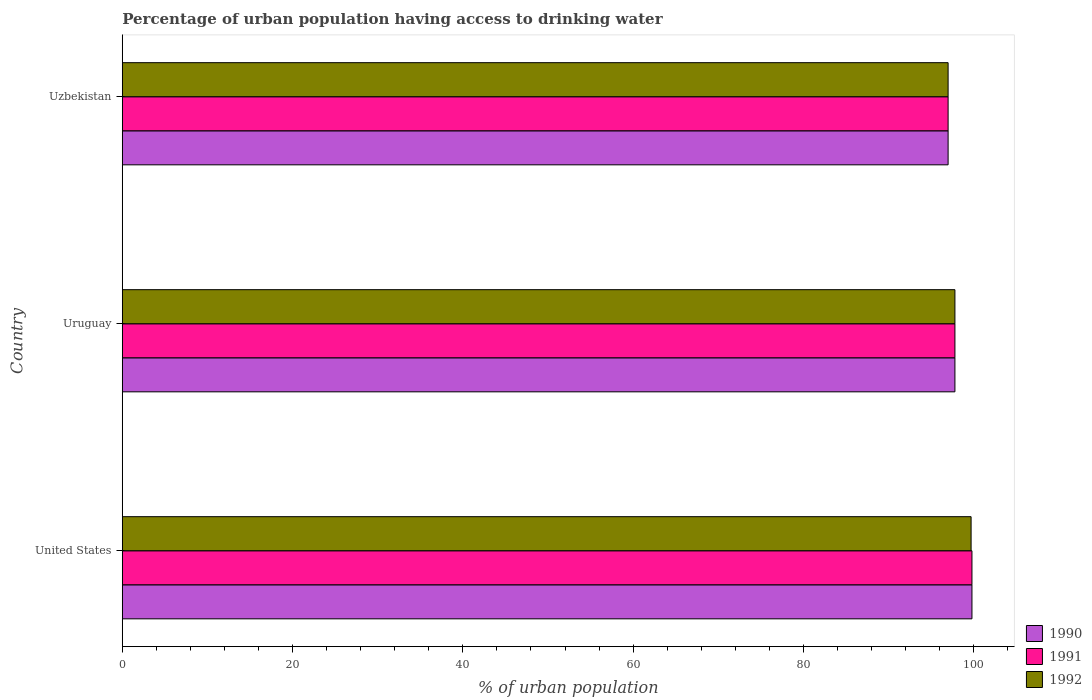How many different coloured bars are there?
Offer a very short reply. 3. Are the number of bars on each tick of the Y-axis equal?
Provide a short and direct response. Yes. How many bars are there on the 2nd tick from the top?
Make the answer very short. 3. What is the label of the 3rd group of bars from the top?
Your answer should be compact. United States. In how many cases, is the number of bars for a given country not equal to the number of legend labels?
Provide a succinct answer. 0. What is the percentage of urban population having access to drinking water in 1990 in Uzbekistan?
Your answer should be compact. 97. Across all countries, what is the maximum percentage of urban population having access to drinking water in 1990?
Provide a succinct answer. 99.8. Across all countries, what is the minimum percentage of urban population having access to drinking water in 1992?
Keep it short and to the point. 97. In which country was the percentage of urban population having access to drinking water in 1992 minimum?
Ensure brevity in your answer.  Uzbekistan. What is the total percentage of urban population having access to drinking water in 1992 in the graph?
Your answer should be compact. 294.5. What is the difference between the percentage of urban population having access to drinking water in 1990 in United States and that in Uruguay?
Your answer should be compact. 2. What is the difference between the percentage of urban population having access to drinking water in 1990 in United States and the percentage of urban population having access to drinking water in 1992 in Uruguay?
Provide a succinct answer. 2. What is the average percentage of urban population having access to drinking water in 1990 per country?
Provide a short and direct response. 98.2. What is the difference between the percentage of urban population having access to drinking water in 1990 and percentage of urban population having access to drinking water in 1992 in Uzbekistan?
Provide a succinct answer. 0. In how many countries, is the percentage of urban population having access to drinking water in 1990 greater than 20 %?
Provide a succinct answer. 3. What is the ratio of the percentage of urban population having access to drinking water in 1990 in United States to that in Uzbekistan?
Offer a very short reply. 1.03. Is the percentage of urban population having access to drinking water in 1992 in United States less than that in Uruguay?
Offer a very short reply. No. Is the difference between the percentage of urban population having access to drinking water in 1990 in United States and Uruguay greater than the difference between the percentage of urban population having access to drinking water in 1992 in United States and Uruguay?
Ensure brevity in your answer.  Yes. What is the difference between the highest and the second highest percentage of urban population having access to drinking water in 1990?
Make the answer very short. 2. What is the difference between the highest and the lowest percentage of urban population having access to drinking water in 1992?
Make the answer very short. 2.7. In how many countries, is the percentage of urban population having access to drinking water in 1990 greater than the average percentage of urban population having access to drinking water in 1990 taken over all countries?
Your answer should be compact. 1. What does the 3rd bar from the top in United States represents?
Provide a short and direct response. 1990. What does the 3rd bar from the bottom in Uzbekistan represents?
Provide a succinct answer. 1992. What is the difference between two consecutive major ticks on the X-axis?
Give a very brief answer. 20. Are the values on the major ticks of X-axis written in scientific E-notation?
Your response must be concise. No. Does the graph contain any zero values?
Your response must be concise. No. Where does the legend appear in the graph?
Provide a succinct answer. Bottom right. How many legend labels are there?
Give a very brief answer. 3. What is the title of the graph?
Offer a terse response. Percentage of urban population having access to drinking water. What is the label or title of the X-axis?
Give a very brief answer. % of urban population. What is the % of urban population in 1990 in United States?
Give a very brief answer. 99.8. What is the % of urban population of 1991 in United States?
Ensure brevity in your answer.  99.8. What is the % of urban population of 1992 in United States?
Give a very brief answer. 99.7. What is the % of urban population in 1990 in Uruguay?
Your answer should be very brief. 97.8. What is the % of urban population of 1991 in Uruguay?
Keep it short and to the point. 97.8. What is the % of urban population in 1992 in Uruguay?
Your response must be concise. 97.8. What is the % of urban population in 1990 in Uzbekistan?
Your answer should be very brief. 97. What is the % of urban population of 1991 in Uzbekistan?
Offer a terse response. 97. What is the % of urban population in 1992 in Uzbekistan?
Your response must be concise. 97. Across all countries, what is the maximum % of urban population of 1990?
Give a very brief answer. 99.8. Across all countries, what is the maximum % of urban population of 1991?
Keep it short and to the point. 99.8. Across all countries, what is the maximum % of urban population of 1992?
Provide a succinct answer. 99.7. Across all countries, what is the minimum % of urban population of 1990?
Keep it short and to the point. 97. Across all countries, what is the minimum % of urban population of 1991?
Your answer should be compact. 97. Across all countries, what is the minimum % of urban population of 1992?
Your answer should be very brief. 97. What is the total % of urban population in 1990 in the graph?
Offer a terse response. 294.6. What is the total % of urban population in 1991 in the graph?
Give a very brief answer. 294.6. What is the total % of urban population in 1992 in the graph?
Offer a very short reply. 294.5. What is the difference between the % of urban population in 1990 in United States and that in Uruguay?
Provide a short and direct response. 2. What is the difference between the % of urban population of 1991 in United States and that in Uruguay?
Offer a very short reply. 2. What is the difference between the % of urban population in 1991 in United States and that in Uzbekistan?
Provide a succinct answer. 2.8. What is the difference between the % of urban population in 1990 in United States and the % of urban population in 1991 in Uruguay?
Keep it short and to the point. 2. What is the difference between the % of urban population of 1991 in United States and the % of urban population of 1992 in Uruguay?
Make the answer very short. 2. What is the difference between the % of urban population in 1990 in United States and the % of urban population in 1991 in Uzbekistan?
Your answer should be compact. 2.8. What is the difference between the % of urban population in 1991 in United States and the % of urban population in 1992 in Uzbekistan?
Your response must be concise. 2.8. What is the difference between the % of urban population in 1990 in Uruguay and the % of urban population in 1992 in Uzbekistan?
Ensure brevity in your answer.  0.8. What is the difference between the % of urban population in 1991 in Uruguay and the % of urban population in 1992 in Uzbekistan?
Give a very brief answer. 0.8. What is the average % of urban population of 1990 per country?
Provide a succinct answer. 98.2. What is the average % of urban population of 1991 per country?
Offer a terse response. 98.2. What is the average % of urban population of 1992 per country?
Provide a succinct answer. 98.17. What is the difference between the % of urban population of 1991 and % of urban population of 1992 in United States?
Your answer should be compact. 0.1. What is the difference between the % of urban population in 1990 and % of urban population in 1991 in Uzbekistan?
Your response must be concise. 0. What is the ratio of the % of urban population in 1990 in United States to that in Uruguay?
Provide a short and direct response. 1.02. What is the ratio of the % of urban population of 1991 in United States to that in Uruguay?
Give a very brief answer. 1.02. What is the ratio of the % of urban population of 1992 in United States to that in Uruguay?
Provide a short and direct response. 1.02. What is the ratio of the % of urban population in 1990 in United States to that in Uzbekistan?
Offer a terse response. 1.03. What is the ratio of the % of urban population of 1991 in United States to that in Uzbekistan?
Make the answer very short. 1.03. What is the ratio of the % of urban population in 1992 in United States to that in Uzbekistan?
Give a very brief answer. 1.03. What is the ratio of the % of urban population in 1990 in Uruguay to that in Uzbekistan?
Offer a very short reply. 1.01. What is the ratio of the % of urban population of 1991 in Uruguay to that in Uzbekistan?
Offer a very short reply. 1.01. What is the ratio of the % of urban population in 1992 in Uruguay to that in Uzbekistan?
Your answer should be compact. 1.01. What is the difference between the highest and the second highest % of urban population of 1992?
Your response must be concise. 1.9. What is the difference between the highest and the lowest % of urban population of 1990?
Offer a terse response. 2.8. What is the difference between the highest and the lowest % of urban population of 1992?
Offer a very short reply. 2.7. 